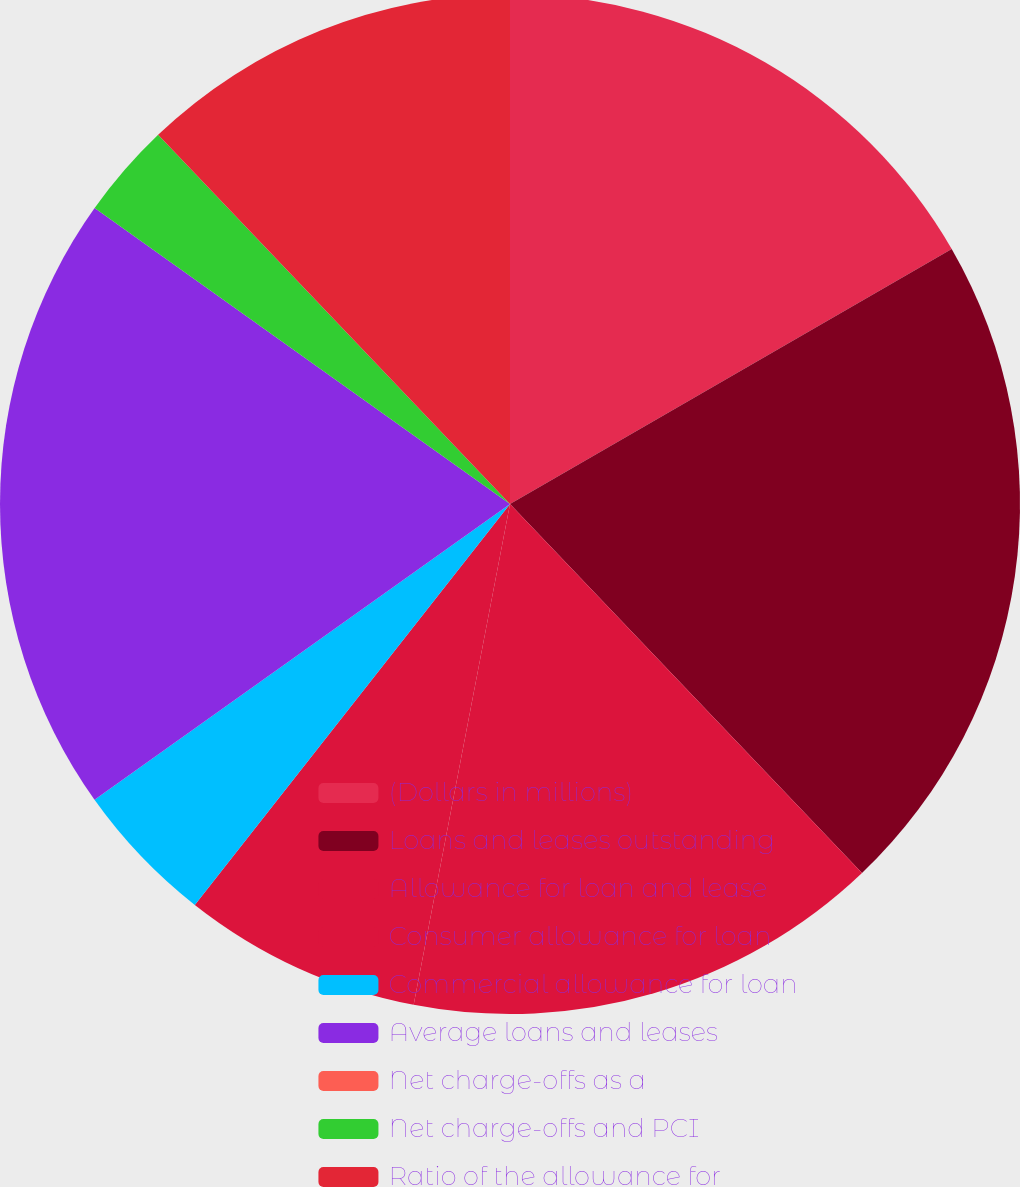<chart> <loc_0><loc_0><loc_500><loc_500><pie_chart><fcel>(Dollars in millions)<fcel>Loans and leases outstanding<fcel>Allowance for loan and lease<fcel>Consumer allowance for loan<fcel>Commercial allowance for loan<fcel>Average loans and leases<fcel>Net charge-offs as a<fcel>Net charge-offs and PCI<fcel>Ratio of the allowance for<nl><fcel>16.67%<fcel>21.21%<fcel>15.15%<fcel>7.58%<fcel>4.55%<fcel>19.7%<fcel>0.0%<fcel>3.03%<fcel>12.12%<nl></chart> 